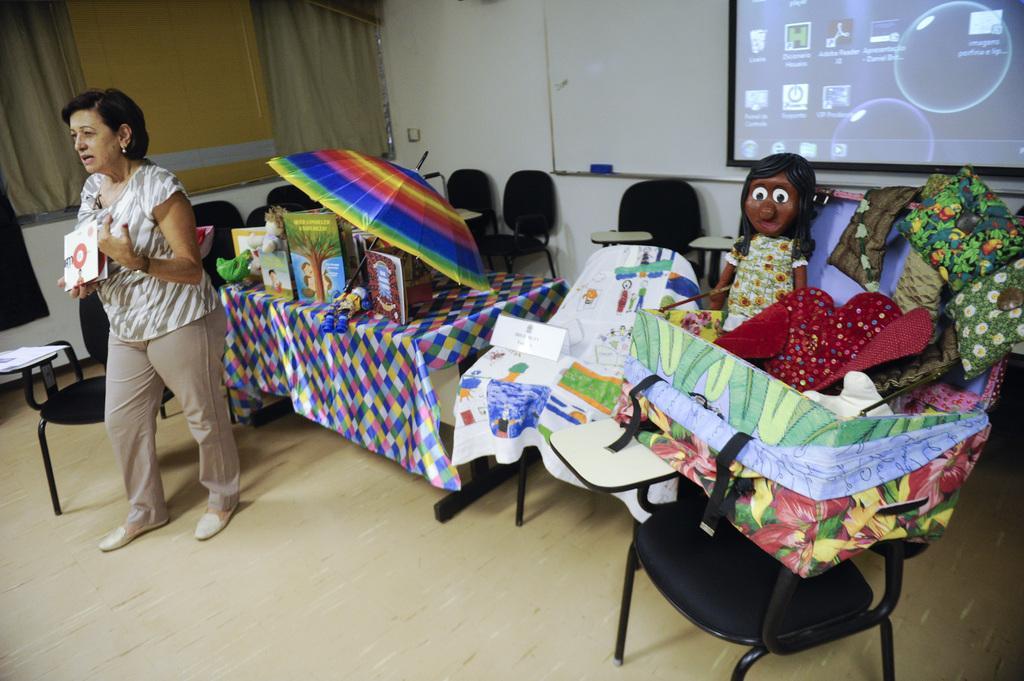How would you summarize this image in a sentence or two? This picture is clicked inside a room. Woman in white and grey shirt is holding book in her hands and she is standing and I think she is trying to talk something. Behind her, we see a table with colorful cloth placed on it and on table, we see umbrella, book and many toys. Bedside table, we see chair on which a box containing mat is placed on the chair. Behind the chair, we see a doll wearing white, green and yellow dress. On the right top of the picture, we see television or a monitor on which icon are displayed. 